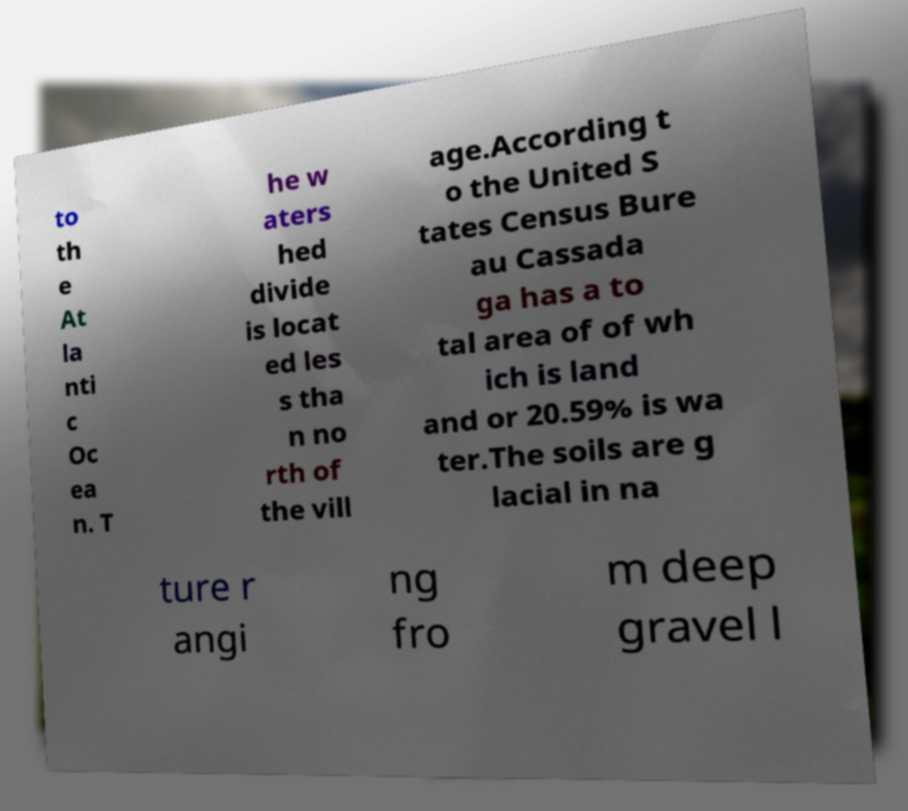What messages or text are displayed in this image? I need them in a readable, typed format. to th e At la nti c Oc ea n. T he w aters hed divide is locat ed les s tha n no rth of the vill age.According t o the United S tates Census Bure au Cassada ga has a to tal area of of wh ich is land and or 20.59% is wa ter.The soils are g lacial in na ture r angi ng fro m deep gravel l 